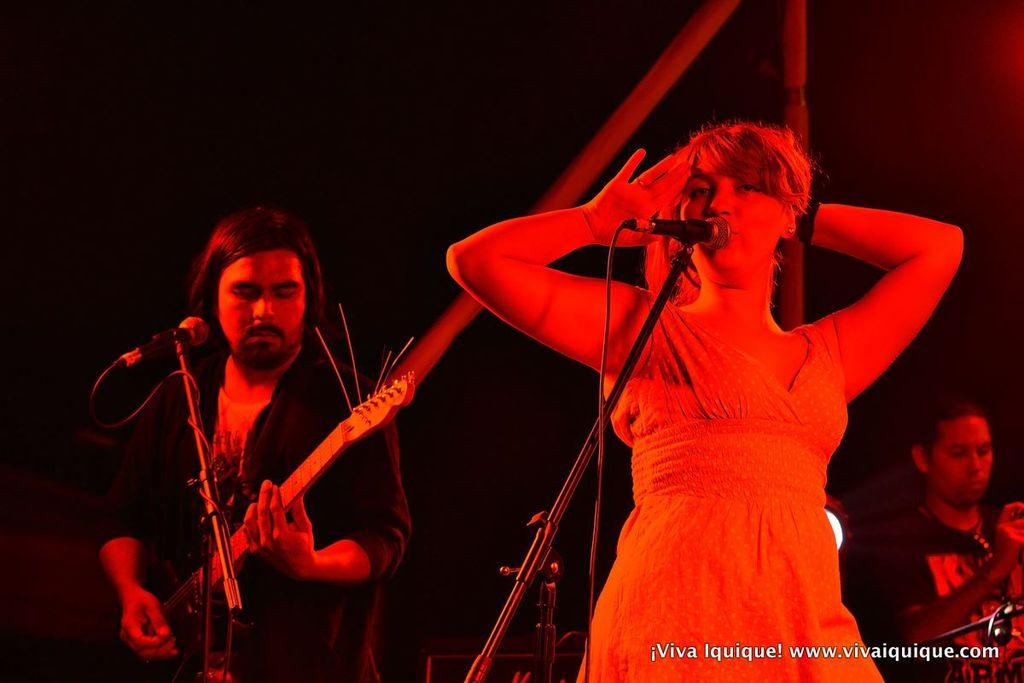Who are the people in the image? There is a man and a woman in the image. What are the man and woman doing in the image? The man and woman are singing on a microphone. What instrument is the man playing in the image? The man is playing a guitar. How many patches can be seen on the guitar in the image? There is no guitar with patches present in the image; the man is playing a guitar without any visible patches. 